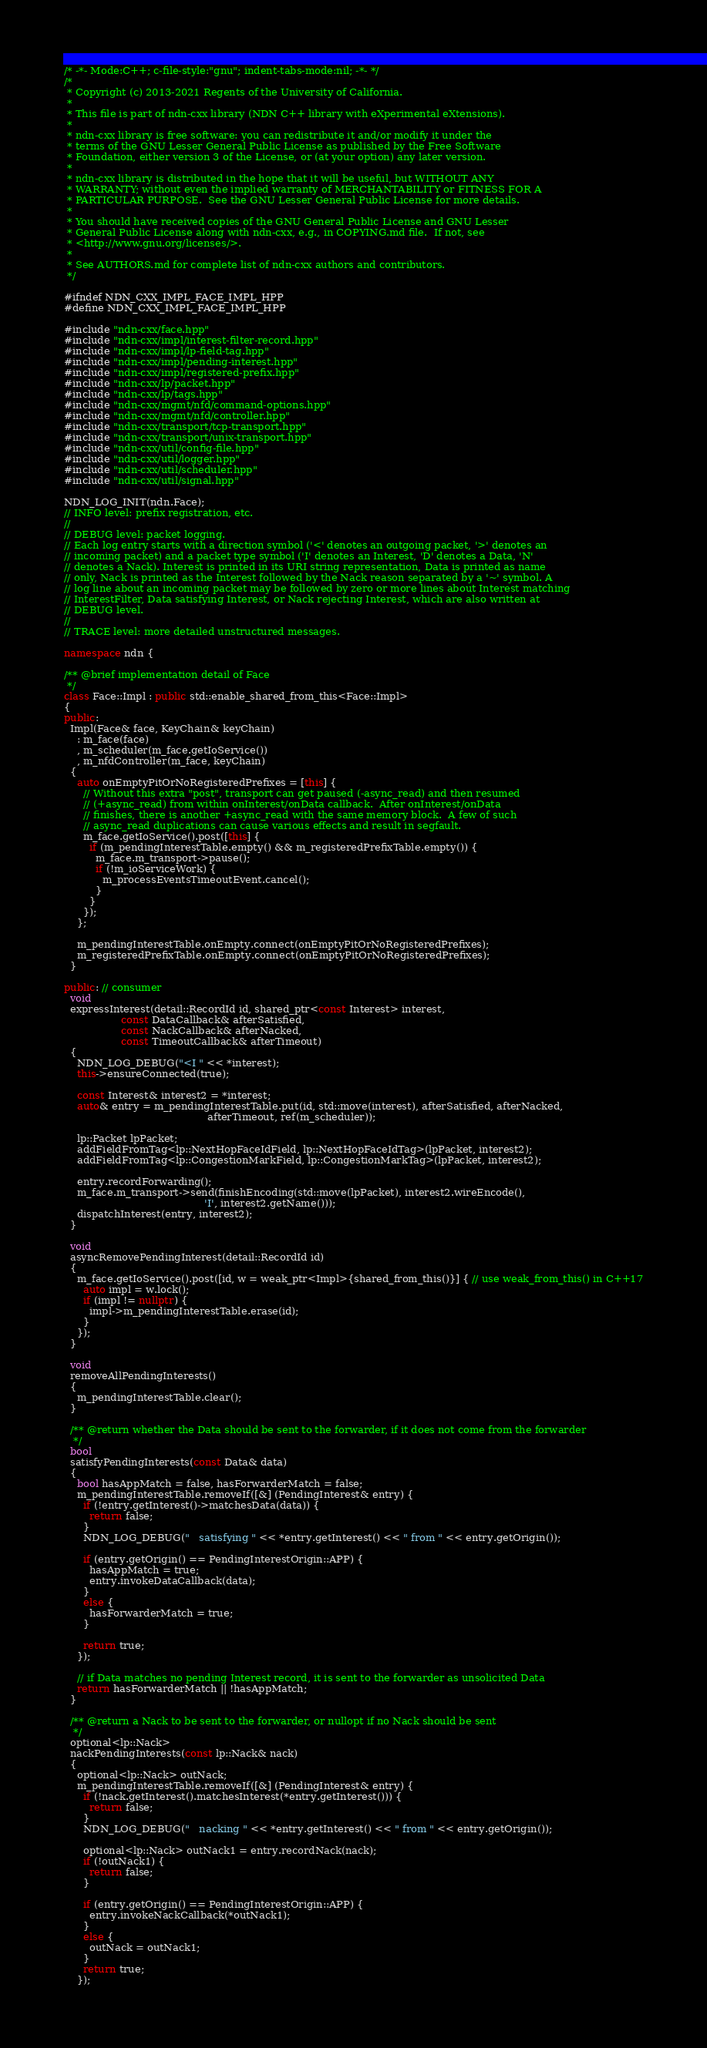<code> <loc_0><loc_0><loc_500><loc_500><_C++_>/* -*- Mode:C++; c-file-style:"gnu"; indent-tabs-mode:nil; -*- */
/*
 * Copyright (c) 2013-2021 Regents of the University of California.
 *
 * This file is part of ndn-cxx library (NDN C++ library with eXperimental eXtensions).
 *
 * ndn-cxx library is free software: you can redistribute it and/or modify it under the
 * terms of the GNU Lesser General Public License as published by the Free Software
 * Foundation, either version 3 of the License, or (at your option) any later version.
 *
 * ndn-cxx library is distributed in the hope that it will be useful, but WITHOUT ANY
 * WARRANTY; without even the implied warranty of MERCHANTABILITY or FITNESS FOR A
 * PARTICULAR PURPOSE.  See the GNU Lesser General Public License for more details.
 *
 * You should have received copies of the GNU General Public License and GNU Lesser
 * General Public License along with ndn-cxx, e.g., in COPYING.md file.  If not, see
 * <http://www.gnu.org/licenses/>.
 *
 * See AUTHORS.md for complete list of ndn-cxx authors and contributors.
 */

#ifndef NDN_CXX_IMPL_FACE_IMPL_HPP
#define NDN_CXX_IMPL_FACE_IMPL_HPP

#include "ndn-cxx/face.hpp"
#include "ndn-cxx/impl/interest-filter-record.hpp"
#include "ndn-cxx/impl/lp-field-tag.hpp"
#include "ndn-cxx/impl/pending-interest.hpp"
#include "ndn-cxx/impl/registered-prefix.hpp"
#include "ndn-cxx/lp/packet.hpp"
#include "ndn-cxx/lp/tags.hpp"
#include "ndn-cxx/mgmt/nfd/command-options.hpp"
#include "ndn-cxx/mgmt/nfd/controller.hpp"
#include "ndn-cxx/transport/tcp-transport.hpp"
#include "ndn-cxx/transport/unix-transport.hpp"
#include "ndn-cxx/util/config-file.hpp"
#include "ndn-cxx/util/logger.hpp"
#include "ndn-cxx/util/scheduler.hpp"
#include "ndn-cxx/util/signal.hpp"

NDN_LOG_INIT(ndn.Face);
// INFO level: prefix registration, etc.
//
// DEBUG level: packet logging.
// Each log entry starts with a direction symbol ('<' denotes an outgoing packet, '>' denotes an
// incoming packet) and a packet type symbol ('I' denotes an Interest, 'D' denotes a Data, 'N'
// denotes a Nack). Interest is printed in its URI string representation, Data is printed as name
// only, Nack is printed as the Interest followed by the Nack reason separated by a '~' symbol. A
// log line about an incoming packet may be followed by zero or more lines about Interest matching
// InterestFilter, Data satisfying Interest, or Nack rejecting Interest, which are also written at
// DEBUG level.
//
// TRACE level: more detailed unstructured messages.

namespace ndn {

/** @brief implementation detail of Face
 */
class Face::Impl : public std::enable_shared_from_this<Face::Impl>
{
public:
  Impl(Face& face, KeyChain& keyChain)
    : m_face(face)
    , m_scheduler(m_face.getIoService())
    , m_nfdController(m_face, keyChain)
  {
    auto onEmptyPitOrNoRegisteredPrefixes = [this] {
      // Without this extra "post", transport can get paused (-async_read) and then resumed
      // (+async_read) from within onInterest/onData callback.  After onInterest/onData
      // finishes, there is another +async_read with the same memory block.  A few of such
      // async_read duplications can cause various effects and result in segfault.
      m_face.getIoService().post([this] {
        if (m_pendingInterestTable.empty() && m_registeredPrefixTable.empty()) {
          m_face.m_transport->pause();
          if (!m_ioServiceWork) {
            m_processEventsTimeoutEvent.cancel();
          }
        }
      });
    };

    m_pendingInterestTable.onEmpty.connect(onEmptyPitOrNoRegisteredPrefixes);
    m_registeredPrefixTable.onEmpty.connect(onEmptyPitOrNoRegisteredPrefixes);
  }

public: // consumer
  void
  expressInterest(detail::RecordId id, shared_ptr<const Interest> interest,
                  const DataCallback& afterSatisfied,
                  const NackCallback& afterNacked,
                  const TimeoutCallback& afterTimeout)
  {
    NDN_LOG_DEBUG("<I " << *interest);
    this->ensureConnected(true);

    const Interest& interest2 = *interest;
    auto& entry = m_pendingInterestTable.put(id, std::move(interest), afterSatisfied, afterNacked,
                                             afterTimeout, ref(m_scheduler));

    lp::Packet lpPacket;
    addFieldFromTag<lp::NextHopFaceIdField, lp::NextHopFaceIdTag>(lpPacket, interest2);
    addFieldFromTag<lp::CongestionMarkField, lp::CongestionMarkTag>(lpPacket, interest2);

    entry.recordForwarding();
    m_face.m_transport->send(finishEncoding(std::move(lpPacket), interest2.wireEncode(),
                                            'I', interest2.getName()));
    dispatchInterest(entry, interest2);
  }

  void
  asyncRemovePendingInterest(detail::RecordId id)
  {
    m_face.getIoService().post([id, w = weak_ptr<Impl>{shared_from_this()}] { // use weak_from_this() in C++17
      auto impl = w.lock();
      if (impl != nullptr) {
        impl->m_pendingInterestTable.erase(id);
      }
    });
  }

  void
  removeAllPendingInterests()
  {
    m_pendingInterestTable.clear();
  }

  /** @return whether the Data should be sent to the forwarder, if it does not come from the forwarder
   */
  bool
  satisfyPendingInterests(const Data& data)
  {
    bool hasAppMatch = false, hasForwarderMatch = false;
    m_pendingInterestTable.removeIf([&] (PendingInterest& entry) {
      if (!entry.getInterest()->matchesData(data)) {
        return false;
      }
      NDN_LOG_DEBUG("   satisfying " << *entry.getInterest() << " from " << entry.getOrigin());

      if (entry.getOrigin() == PendingInterestOrigin::APP) {
        hasAppMatch = true;
        entry.invokeDataCallback(data);
      }
      else {
        hasForwarderMatch = true;
      }

      return true;
    });

    // if Data matches no pending Interest record, it is sent to the forwarder as unsolicited Data
    return hasForwarderMatch || !hasAppMatch;
  }

  /** @return a Nack to be sent to the forwarder, or nullopt if no Nack should be sent
   */
  optional<lp::Nack>
  nackPendingInterests(const lp::Nack& nack)
  {
    optional<lp::Nack> outNack;
    m_pendingInterestTable.removeIf([&] (PendingInterest& entry) {
      if (!nack.getInterest().matchesInterest(*entry.getInterest())) {
        return false;
      }
      NDN_LOG_DEBUG("   nacking " << *entry.getInterest() << " from " << entry.getOrigin());

      optional<lp::Nack> outNack1 = entry.recordNack(nack);
      if (!outNack1) {
        return false;
      }

      if (entry.getOrigin() == PendingInterestOrigin::APP) {
        entry.invokeNackCallback(*outNack1);
      }
      else {
        outNack = outNack1;
      }
      return true;
    });
</code> 